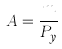<formula> <loc_0><loc_0><loc_500><loc_500>A = \frac { m } { P _ { y } }</formula> 